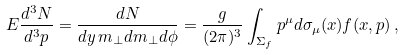Convert formula to latex. <formula><loc_0><loc_0><loc_500><loc_500>E \frac { d ^ { 3 } N } { d ^ { 3 } p } = \frac { d N } { d y \, m _ { \perp } d m _ { \perp } d \phi } = \frac { g } { ( 2 \pi ) ^ { 3 } } \int _ { \Sigma _ { f } } p ^ { \mu } d \sigma _ { \mu } ( x ) f ( x , p ) \, ,</formula> 